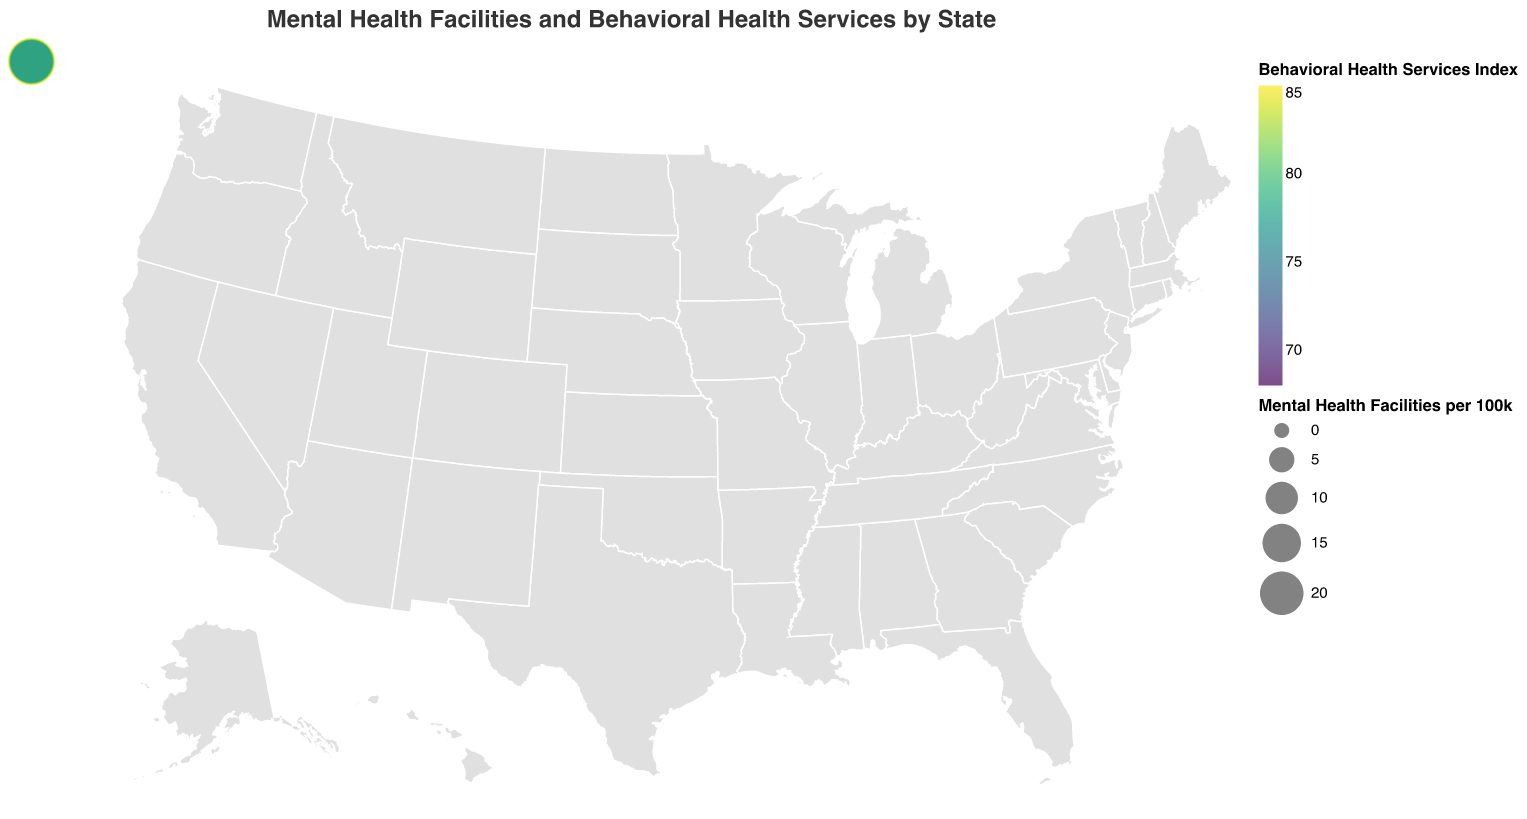Which state has the highest number of mental health facilities per 100k? Look at the circle sizes on the map. Massachusetts has the largest circle, indicating the highest number of facilities per 100k.
Answer: Massachusetts What state has a Behavioral Health Services Index of 83? Check the data points for the Behavioral Health Services Index. Minnesota has a value of 83.
Answer: Minnesota How does Texas compare to California in terms of Mental Health Facilities per 100k? Compare the circle sizes for Texas and California. Texas has a circle indicating 12.5 facilities per 100k, whereas California has 18.7.
Answer: California has more Which states have a Behavioral Health Services Index greater than 80? Check the color gradient of the circles and the corresponding values. Massachusetts (85), New York (82), Minnesota (83), Colorado (80), and New Jersey (81).
Answer: Massachusetts, New York, Minnesota, Colorado, New Jersey Are there more mental health facilities per 100k in Virginia or Georgia? Compare the circle sizes for Virginia and Georgia. Virginia has a circle indicating 16.4 facilities per 100k, whereas Georgia has 13.6.
Answer: Virginia Which state has the lowest Behavioral Health Services Index? Identify the circle with the lightest color and check the data. Texas has the lowest index at 68.
Answer: Texas What is the difference in the Behavioral Health Services Index between Illinois and Ohio? Look at the color coding and corresponding indices: Illinois (76) and Ohio (72). Subtract the lower from the higher.
Answer: 4 Is there a positive correlation between the number of mental health facilities per 100k and the Behavioral Health Services Index? Compare the relative sizes of circles (facilities per 100k) with their colors (index). Generally, states with larger circles tend to have darker colors (higher index), suggesting a positive correlation.
Answer: Yes Which state has nearly the same Behavioral Health Services Index as Washington? Check for states with similar color shades and corresponding indices. Wisconsin (78) and Washington (78) have the same index.
Answer: Wisconsin Are states with higher numbers of mental health facilities per 100k always having higher Behavioral Health Services Indexes? Cross-check circles with larger sizes against their color intensity. Though often correlated, some exceptions exist, like New Jersey and Wisconsin having different indices despite close facilities per 100k.
Answer: Not always 